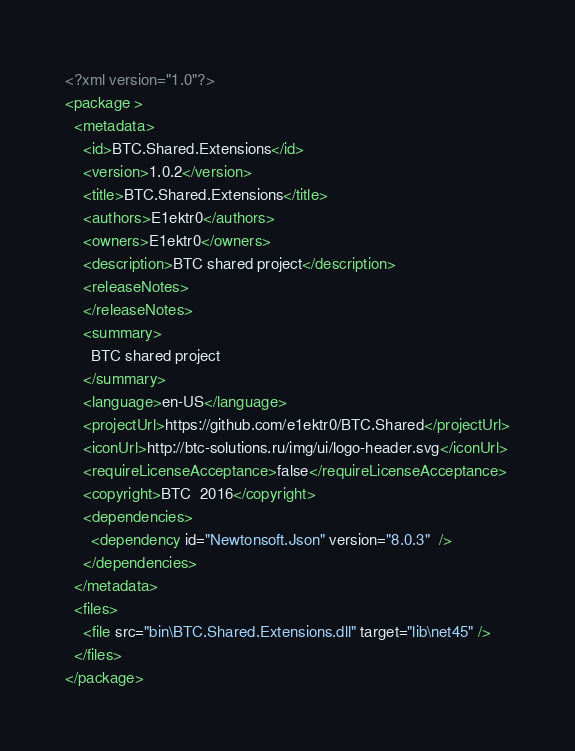<code> <loc_0><loc_0><loc_500><loc_500><_XML_><?xml version="1.0"?>
<package >
  <metadata>
    <id>BTC.Shared.Extensions</id>
    <version>1.0.2</version>
    <title>BTC.Shared.Extensions</title>
    <authors>E1ektr0</authors>
    <owners>E1ektr0</owners>
    <description>BTC shared project</description>
    <releaseNotes>
    </releaseNotes>
    <summary>
      BTC shared project
    </summary>
    <language>en-US</language>
    <projectUrl>https://github.com/e1ektr0/BTC.Shared</projectUrl>
    <iconUrl>http://btc-solutions.ru/img/ui/logo-header.svg</iconUrl>
    <requireLicenseAcceptance>false</requireLicenseAcceptance>
    <copyright>BTC  2016</copyright>
    <dependencies>
      <dependency id="Newtonsoft.Json" version="8.0.3"  />
    </dependencies>
  </metadata>
  <files>
    <file src="bin\BTC.Shared.Extensions.dll" target="lib\net45" />
  </files>
</package></code> 